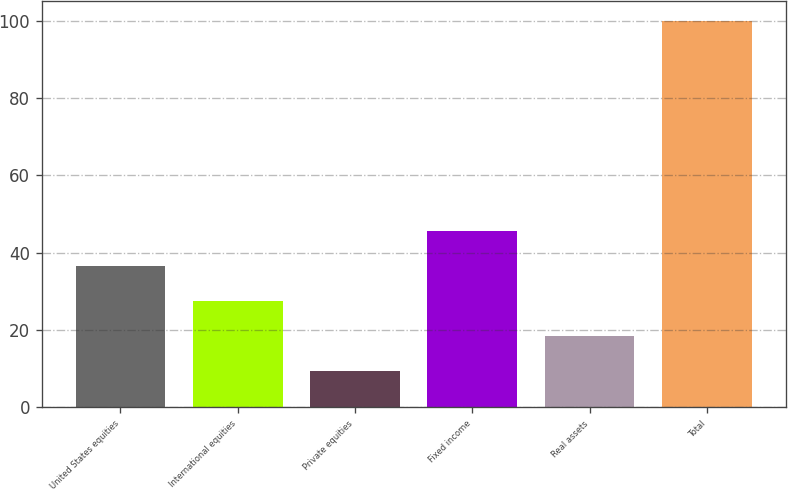<chart> <loc_0><loc_0><loc_500><loc_500><bar_chart><fcel>United States equities<fcel>International equities<fcel>Private equities<fcel>Fixed income<fcel>Real assets<fcel>Total<nl><fcel>36.65<fcel>27.6<fcel>9.5<fcel>45.7<fcel>18.55<fcel>100<nl></chart> 